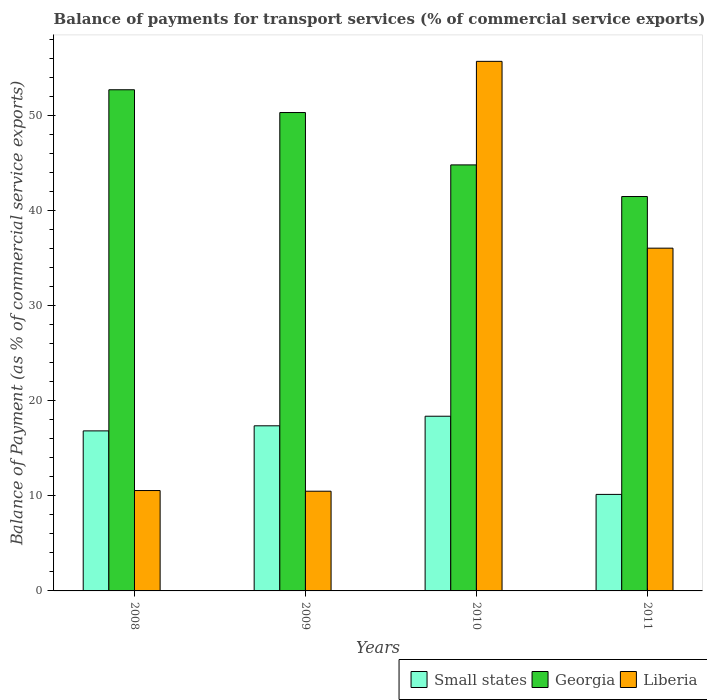How many groups of bars are there?
Offer a terse response. 4. Are the number of bars per tick equal to the number of legend labels?
Provide a short and direct response. Yes. Are the number of bars on each tick of the X-axis equal?
Your answer should be very brief. Yes. How many bars are there on the 2nd tick from the left?
Make the answer very short. 3. How many bars are there on the 1st tick from the right?
Provide a succinct answer. 3. What is the balance of payments for transport services in Small states in 2008?
Make the answer very short. 16.84. Across all years, what is the maximum balance of payments for transport services in Small states?
Your answer should be compact. 18.38. Across all years, what is the minimum balance of payments for transport services in Georgia?
Keep it short and to the point. 41.49. In which year was the balance of payments for transport services in Small states minimum?
Make the answer very short. 2011. What is the total balance of payments for transport services in Small states in the graph?
Your answer should be very brief. 62.74. What is the difference between the balance of payments for transport services in Small states in 2008 and that in 2009?
Your response must be concise. -0.53. What is the difference between the balance of payments for transport services in Liberia in 2011 and the balance of payments for transport services in Small states in 2009?
Your answer should be very brief. 18.69. What is the average balance of payments for transport services in Small states per year?
Offer a very short reply. 15.69. In the year 2011, what is the difference between the balance of payments for transport services in Small states and balance of payments for transport services in Georgia?
Make the answer very short. -31.34. In how many years, is the balance of payments for transport services in Liberia greater than 14 %?
Keep it short and to the point. 2. What is the ratio of the balance of payments for transport services in Small states in 2009 to that in 2010?
Provide a short and direct response. 0.95. Is the difference between the balance of payments for transport services in Small states in 2009 and 2011 greater than the difference between the balance of payments for transport services in Georgia in 2009 and 2011?
Your answer should be compact. No. What is the difference between the highest and the second highest balance of payments for transport services in Small states?
Make the answer very short. 1.01. What is the difference between the highest and the lowest balance of payments for transport services in Georgia?
Make the answer very short. 11.23. Is the sum of the balance of payments for transport services in Small states in 2008 and 2009 greater than the maximum balance of payments for transport services in Liberia across all years?
Ensure brevity in your answer.  No. What does the 1st bar from the left in 2010 represents?
Your answer should be very brief. Small states. What does the 3rd bar from the right in 2010 represents?
Offer a terse response. Small states. Is it the case that in every year, the sum of the balance of payments for transport services in Liberia and balance of payments for transport services in Georgia is greater than the balance of payments for transport services in Small states?
Your response must be concise. Yes. How many bars are there?
Your answer should be very brief. 12. Are all the bars in the graph horizontal?
Your answer should be very brief. No. Are the values on the major ticks of Y-axis written in scientific E-notation?
Offer a very short reply. No. Does the graph contain grids?
Your response must be concise. No. How many legend labels are there?
Provide a short and direct response. 3. How are the legend labels stacked?
Keep it short and to the point. Horizontal. What is the title of the graph?
Provide a succinct answer. Balance of payments for transport services (% of commercial service exports). What is the label or title of the Y-axis?
Provide a succinct answer. Balance of Payment (as % of commercial service exports). What is the Balance of Payment (as % of commercial service exports) in Small states in 2008?
Offer a very short reply. 16.84. What is the Balance of Payment (as % of commercial service exports) of Georgia in 2008?
Provide a short and direct response. 52.72. What is the Balance of Payment (as % of commercial service exports) in Liberia in 2008?
Offer a very short reply. 10.56. What is the Balance of Payment (as % of commercial service exports) of Small states in 2009?
Make the answer very short. 17.37. What is the Balance of Payment (as % of commercial service exports) of Georgia in 2009?
Keep it short and to the point. 50.33. What is the Balance of Payment (as % of commercial service exports) of Liberia in 2009?
Provide a short and direct response. 10.49. What is the Balance of Payment (as % of commercial service exports) of Small states in 2010?
Provide a short and direct response. 18.38. What is the Balance of Payment (as % of commercial service exports) of Georgia in 2010?
Make the answer very short. 44.82. What is the Balance of Payment (as % of commercial service exports) in Liberia in 2010?
Your response must be concise. 55.71. What is the Balance of Payment (as % of commercial service exports) of Small states in 2011?
Your response must be concise. 10.15. What is the Balance of Payment (as % of commercial service exports) of Georgia in 2011?
Provide a short and direct response. 41.49. What is the Balance of Payment (as % of commercial service exports) in Liberia in 2011?
Your response must be concise. 36.06. Across all years, what is the maximum Balance of Payment (as % of commercial service exports) in Small states?
Offer a terse response. 18.38. Across all years, what is the maximum Balance of Payment (as % of commercial service exports) of Georgia?
Offer a very short reply. 52.72. Across all years, what is the maximum Balance of Payment (as % of commercial service exports) in Liberia?
Provide a succinct answer. 55.71. Across all years, what is the minimum Balance of Payment (as % of commercial service exports) in Small states?
Your response must be concise. 10.15. Across all years, what is the minimum Balance of Payment (as % of commercial service exports) of Georgia?
Offer a very short reply. 41.49. Across all years, what is the minimum Balance of Payment (as % of commercial service exports) of Liberia?
Provide a short and direct response. 10.49. What is the total Balance of Payment (as % of commercial service exports) in Small states in the graph?
Keep it short and to the point. 62.74. What is the total Balance of Payment (as % of commercial service exports) of Georgia in the graph?
Offer a very short reply. 189.36. What is the total Balance of Payment (as % of commercial service exports) of Liberia in the graph?
Make the answer very short. 112.82. What is the difference between the Balance of Payment (as % of commercial service exports) of Small states in 2008 and that in 2009?
Your response must be concise. -0.53. What is the difference between the Balance of Payment (as % of commercial service exports) of Georgia in 2008 and that in 2009?
Provide a short and direct response. 2.4. What is the difference between the Balance of Payment (as % of commercial service exports) of Liberia in 2008 and that in 2009?
Provide a succinct answer. 0.07. What is the difference between the Balance of Payment (as % of commercial service exports) of Small states in 2008 and that in 2010?
Provide a succinct answer. -1.54. What is the difference between the Balance of Payment (as % of commercial service exports) in Georgia in 2008 and that in 2010?
Your answer should be compact. 7.9. What is the difference between the Balance of Payment (as % of commercial service exports) of Liberia in 2008 and that in 2010?
Make the answer very short. -45.15. What is the difference between the Balance of Payment (as % of commercial service exports) of Small states in 2008 and that in 2011?
Make the answer very short. 6.68. What is the difference between the Balance of Payment (as % of commercial service exports) of Georgia in 2008 and that in 2011?
Ensure brevity in your answer.  11.23. What is the difference between the Balance of Payment (as % of commercial service exports) in Liberia in 2008 and that in 2011?
Provide a succinct answer. -25.5. What is the difference between the Balance of Payment (as % of commercial service exports) of Small states in 2009 and that in 2010?
Provide a short and direct response. -1.01. What is the difference between the Balance of Payment (as % of commercial service exports) of Georgia in 2009 and that in 2010?
Give a very brief answer. 5.51. What is the difference between the Balance of Payment (as % of commercial service exports) in Liberia in 2009 and that in 2010?
Offer a terse response. -45.22. What is the difference between the Balance of Payment (as % of commercial service exports) of Small states in 2009 and that in 2011?
Your answer should be very brief. 7.22. What is the difference between the Balance of Payment (as % of commercial service exports) in Georgia in 2009 and that in 2011?
Your answer should be very brief. 8.84. What is the difference between the Balance of Payment (as % of commercial service exports) in Liberia in 2009 and that in 2011?
Keep it short and to the point. -25.57. What is the difference between the Balance of Payment (as % of commercial service exports) of Small states in 2010 and that in 2011?
Offer a terse response. 8.22. What is the difference between the Balance of Payment (as % of commercial service exports) in Georgia in 2010 and that in 2011?
Offer a terse response. 3.33. What is the difference between the Balance of Payment (as % of commercial service exports) of Liberia in 2010 and that in 2011?
Your answer should be compact. 19.65. What is the difference between the Balance of Payment (as % of commercial service exports) in Small states in 2008 and the Balance of Payment (as % of commercial service exports) in Georgia in 2009?
Provide a short and direct response. -33.49. What is the difference between the Balance of Payment (as % of commercial service exports) in Small states in 2008 and the Balance of Payment (as % of commercial service exports) in Liberia in 2009?
Offer a very short reply. 6.35. What is the difference between the Balance of Payment (as % of commercial service exports) in Georgia in 2008 and the Balance of Payment (as % of commercial service exports) in Liberia in 2009?
Provide a short and direct response. 42.23. What is the difference between the Balance of Payment (as % of commercial service exports) in Small states in 2008 and the Balance of Payment (as % of commercial service exports) in Georgia in 2010?
Your answer should be very brief. -27.98. What is the difference between the Balance of Payment (as % of commercial service exports) in Small states in 2008 and the Balance of Payment (as % of commercial service exports) in Liberia in 2010?
Offer a terse response. -38.88. What is the difference between the Balance of Payment (as % of commercial service exports) of Georgia in 2008 and the Balance of Payment (as % of commercial service exports) of Liberia in 2010?
Make the answer very short. -2.99. What is the difference between the Balance of Payment (as % of commercial service exports) of Small states in 2008 and the Balance of Payment (as % of commercial service exports) of Georgia in 2011?
Provide a short and direct response. -24.66. What is the difference between the Balance of Payment (as % of commercial service exports) of Small states in 2008 and the Balance of Payment (as % of commercial service exports) of Liberia in 2011?
Your answer should be very brief. -19.22. What is the difference between the Balance of Payment (as % of commercial service exports) in Georgia in 2008 and the Balance of Payment (as % of commercial service exports) in Liberia in 2011?
Your response must be concise. 16.67. What is the difference between the Balance of Payment (as % of commercial service exports) in Small states in 2009 and the Balance of Payment (as % of commercial service exports) in Georgia in 2010?
Provide a succinct answer. -27.45. What is the difference between the Balance of Payment (as % of commercial service exports) in Small states in 2009 and the Balance of Payment (as % of commercial service exports) in Liberia in 2010?
Ensure brevity in your answer.  -38.34. What is the difference between the Balance of Payment (as % of commercial service exports) of Georgia in 2009 and the Balance of Payment (as % of commercial service exports) of Liberia in 2010?
Offer a terse response. -5.39. What is the difference between the Balance of Payment (as % of commercial service exports) of Small states in 2009 and the Balance of Payment (as % of commercial service exports) of Georgia in 2011?
Keep it short and to the point. -24.12. What is the difference between the Balance of Payment (as % of commercial service exports) in Small states in 2009 and the Balance of Payment (as % of commercial service exports) in Liberia in 2011?
Your answer should be very brief. -18.69. What is the difference between the Balance of Payment (as % of commercial service exports) in Georgia in 2009 and the Balance of Payment (as % of commercial service exports) in Liberia in 2011?
Your response must be concise. 14.27. What is the difference between the Balance of Payment (as % of commercial service exports) in Small states in 2010 and the Balance of Payment (as % of commercial service exports) in Georgia in 2011?
Your response must be concise. -23.11. What is the difference between the Balance of Payment (as % of commercial service exports) in Small states in 2010 and the Balance of Payment (as % of commercial service exports) in Liberia in 2011?
Ensure brevity in your answer.  -17.68. What is the difference between the Balance of Payment (as % of commercial service exports) in Georgia in 2010 and the Balance of Payment (as % of commercial service exports) in Liberia in 2011?
Your response must be concise. 8.76. What is the average Balance of Payment (as % of commercial service exports) of Small states per year?
Provide a short and direct response. 15.69. What is the average Balance of Payment (as % of commercial service exports) in Georgia per year?
Offer a terse response. 47.34. What is the average Balance of Payment (as % of commercial service exports) in Liberia per year?
Offer a very short reply. 28.21. In the year 2008, what is the difference between the Balance of Payment (as % of commercial service exports) of Small states and Balance of Payment (as % of commercial service exports) of Georgia?
Your answer should be compact. -35.89. In the year 2008, what is the difference between the Balance of Payment (as % of commercial service exports) of Small states and Balance of Payment (as % of commercial service exports) of Liberia?
Make the answer very short. 6.28. In the year 2008, what is the difference between the Balance of Payment (as % of commercial service exports) of Georgia and Balance of Payment (as % of commercial service exports) of Liberia?
Ensure brevity in your answer.  42.16. In the year 2009, what is the difference between the Balance of Payment (as % of commercial service exports) of Small states and Balance of Payment (as % of commercial service exports) of Georgia?
Ensure brevity in your answer.  -32.96. In the year 2009, what is the difference between the Balance of Payment (as % of commercial service exports) of Small states and Balance of Payment (as % of commercial service exports) of Liberia?
Offer a terse response. 6.88. In the year 2009, what is the difference between the Balance of Payment (as % of commercial service exports) of Georgia and Balance of Payment (as % of commercial service exports) of Liberia?
Keep it short and to the point. 39.84. In the year 2010, what is the difference between the Balance of Payment (as % of commercial service exports) of Small states and Balance of Payment (as % of commercial service exports) of Georgia?
Offer a very short reply. -26.44. In the year 2010, what is the difference between the Balance of Payment (as % of commercial service exports) of Small states and Balance of Payment (as % of commercial service exports) of Liberia?
Provide a short and direct response. -37.33. In the year 2010, what is the difference between the Balance of Payment (as % of commercial service exports) of Georgia and Balance of Payment (as % of commercial service exports) of Liberia?
Provide a succinct answer. -10.89. In the year 2011, what is the difference between the Balance of Payment (as % of commercial service exports) of Small states and Balance of Payment (as % of commercial service exports) of Georgia?
Your answer should be compact. -31.34. In the year 2011, what is the difference between the Balance of Payment (as % of commercial service exports) of Small states and Balance of Payment (as % of commercial service exports) of Liberia?
Your answer should be compact. -25.9. In the year 2011, what is the difference between the Balance of Payment (as % of commercial service exports) of Georgia and Balance of Payment (as % of commercial service exports) of Liberia?
Provide a succinct answer. 5.43. What is the ratio of the Balance of Payment (as % of commercial service exports) of Small states in 2008 to that in 2009?
Provide a succinct answer. 0.97. What is the ratio of the Balance of Payment (as % of commercial service exports) in Georgia in 2008 to that in 2009?
Make the answer very short. 1.05. What is the ratio of the Balance of Payment (as % of commercial service exports) of Liberia in 2008 to that in 2009?
Your response must be concise. 1.01. What is the ratio of the Balance of Payment (as % of commercial service exports) in Small states in 2008 to that in 2010?
Offer a terse response. 0.92. What is the ratio of the Balance of Payment (as % of commercial service exports) of Georgia in 2008 to that in 2010?
Offer a very short reply. 1.18. What is the ratio of the Balance of Payment (as % of commercial service exports) in Liberia in 2008 to that in 2010?
Provide a short and direct response. 0.19. What is the ratio of the Balance of Payment (as % of commercial service exports) of Small states in 2008 to that in 2011?
Give a very brief answer. 1.66. What is the ratio of the Balance of Payment (as % of commercial service exports) in Georgia in 2008 to that in 2011?
Your answer should be compact. 1.27. What is the ratio of the Balance of Payment (as % of commercial service exports) in Liberia in 2008 to that in 2011?
Your response must be concise. 0.29. What is the ratio of the Balance of Payment (as % of commercial service exports) of Small states in 2009 to that in 2010?
Make the answer very short. 0.95. What is the ratio of the Balance of Payment (as % of commercial service exports) in Georgia in 2009 to that in 2010?
Provide a succinct answer. 1.12. What is the ratio of the Balance of Payment (as % of commercial service exports) in Liberia in 2009 to that in 2010?
Give a very brief answer. 0.19. What is the ratio of the Balance of Payment (as % of commercial service exports) in Small states in 2009 to that in 2011?
Provide a short and direct response. 1.71. What is the ratio of the Balance of Payment (as % of commercial service exports) of Georgia in 2009 to that in 2011?
Provide a short and direct response. 1.21. What is the ratio of the Balance of Payment (as % of commercial service exports) in Liberia in 2009 to that in 2011?
Your response must be concise. 0.29. What is the ratio of the Balance of Payment (as % of commercial service exports) in Small states in 2010 to that in 2011?
Offer a terse response. 1.81. What is the ratio of the Balance of Payment (as % of commercial service exports) in Georgia in 2010 to that in 2011?
Give a very brief answer. 1.08. What is the ratio of the Balance of Payment (as % of commercial service exports) of Liberia in 2010 to that in 2011?
Provide a short and direct response. 1.54. What is the difference between the highest and the second highest Balance of Payment (as % of commercial service exports) in Small states?
Provide a short and direct response. 1.01. What is the difference between the highest and the second highest Balance of Payment (as % of commercial service exports) of Georgia?
Give a very brief answer. 2.4. What is the difference between the highest and the second highest Balance of Payment (as % of commercial service exports) of Liberia?
Ensure brevity in your answer.  19.65. What is the difference between the highest and the lowest Balance of Payment (as % of commercial service exports) in Small states?
Make the answer very short. 8.22. What is the difference between the highest and the lowest Balance of Payment (as % of commercial service exports) of Georgia?
Provide a succinct answer. 11.23. What is the difference between the highest and the lowest Balance of Payment (as % of commercial service exports) in Liberia?
Provide a short and direct response. 45.22. 